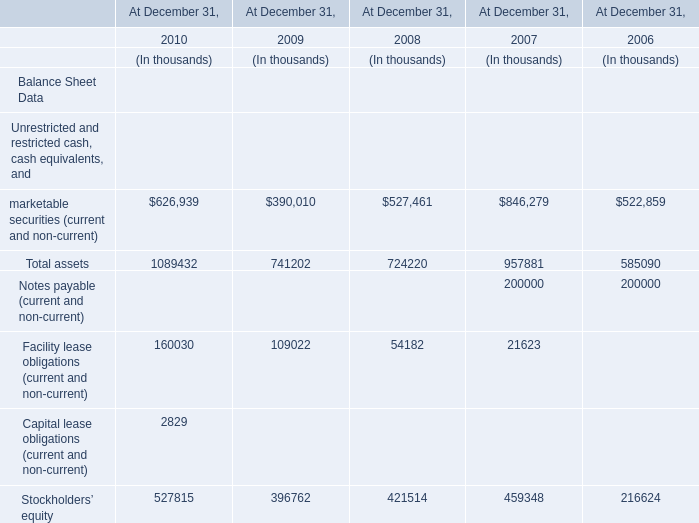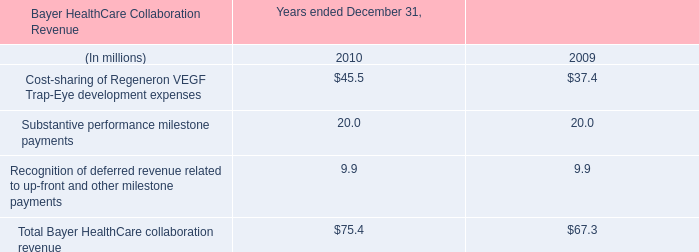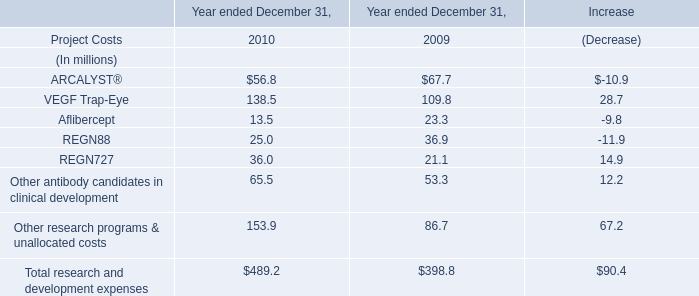what was the total in 2010 and 2009 for arcalyst ae net product sales? 
Computations: ((25.3 + 18.4) * 1000000)
Answer: 43700000.0. 